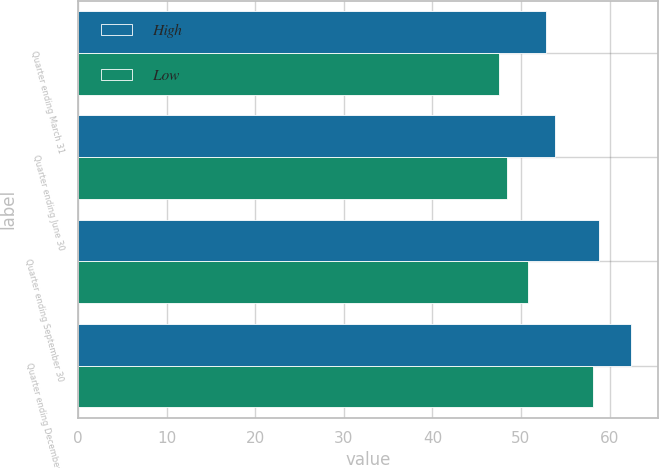Convert chart to OTSL. <chart><loc_0><loc_0><loc_500><loc_500><stacked_bar_chart><ecel><fcel>Quarter ending March 31<fcel>Quarter ending June 30<fcel>Quarter ending September 30<fcel>Quarter ending December 31<nl><fcel>High<fcel>52.88<fcel>53.89<fcel>58.8<fcel>62.37<nl><fcel>Low<fcel>47.5<fcel>48.43<fcel>50.83<fcel>58.1<nl></chart> 